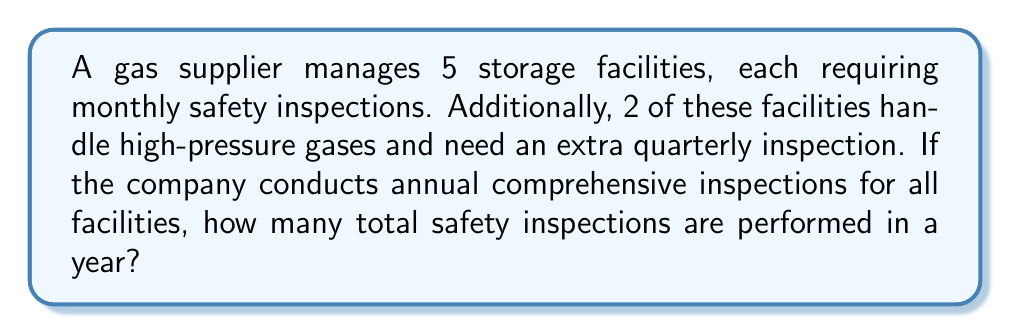Show me your answer to this math problem. Let's break this down step-by-step:

1. Monthly inspections for all facilities:
   $5 \text{ facilities} \times 12 \text{ months} = 60 \text{ inspections}$

2. Quarterly inspections for high-pressure facilities:
   $2 \text{ facilities} \times 4 \text{ quarters} = 8 \text{ inspections}$

3. Annual comprehensive inspections:
   $5 \text{ facilities} \times 1 \text{ annual inspection} = 5 \text{ inspections}$

4. Total number of inspections:
   $$60 + 8 + 5 = 73 \text{ inspections}$$

Therefore, the total number of safety inspections performed in a year is 73.
Answer: 73 